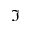<formula> <loc_0><loc_0><loc_500><loc_500>\Im</formula> 